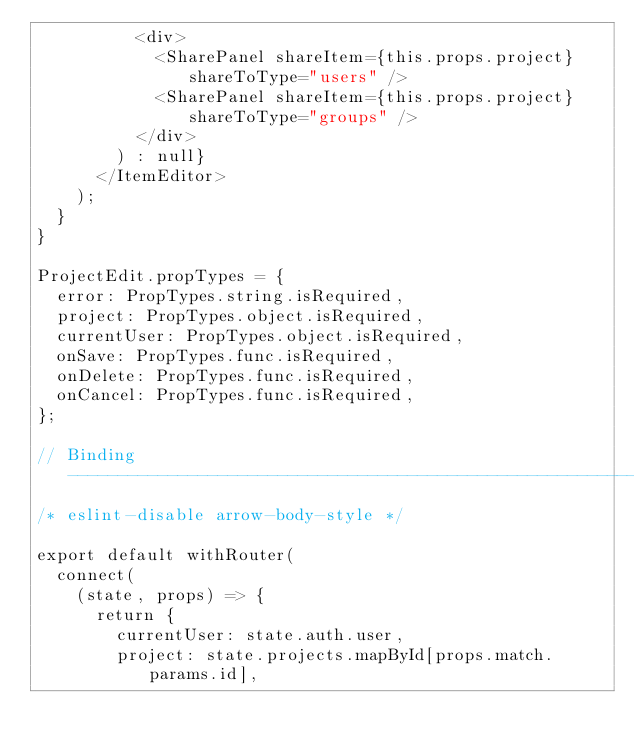Convert code to text. <code><loc_0><loc_0><loc_500><loc_500><_JavaScript_>          <div>
            <SharePanel shareItem={this.props.project} shareToType="users" />
            <SharePanel shareItem={this.props.project} shareToType="groups" />
          </div>
        ) : null}
      </ItemEditor>
    );
  }
}

ProjectEdit.propTypes = {
  error: PropTypes.string.isRequired,
  project: PropTypes.object.isRequired,
  currentUser: PropTypes.object.isRequired,
  onSave: PropTypes.func.isRequired,
  onDelete: PropTypes.func.isRequired,
  onCancel: PropTypes.func.isRequired,
};

// Binding --------------------------------------------------------------------
/* eslint-disable arrow-body-style */

export default withRouter(
  connect(
    (state, props) => {
      return {
        currentUser: state.auth.user,
        project: state.projects.mapById[props.match.params.id],</code> 